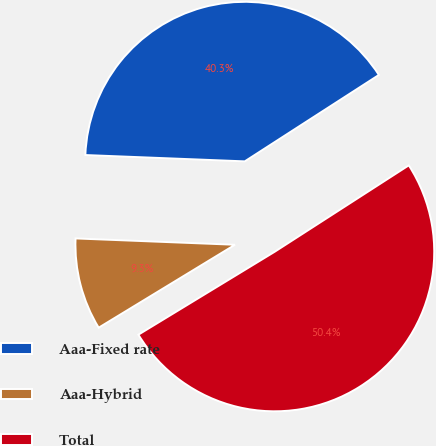Convert chart to OTSL. <chart><loc_0><loc_0><loc_500><loc_500><pie_chart><fcel>Aaa-Fixed rate<fcel>Aaa-Hybrid<fcel>Total<nl><fcel>40.26%<fcel>9.33%<fcel>50.41%<nl></chart> 